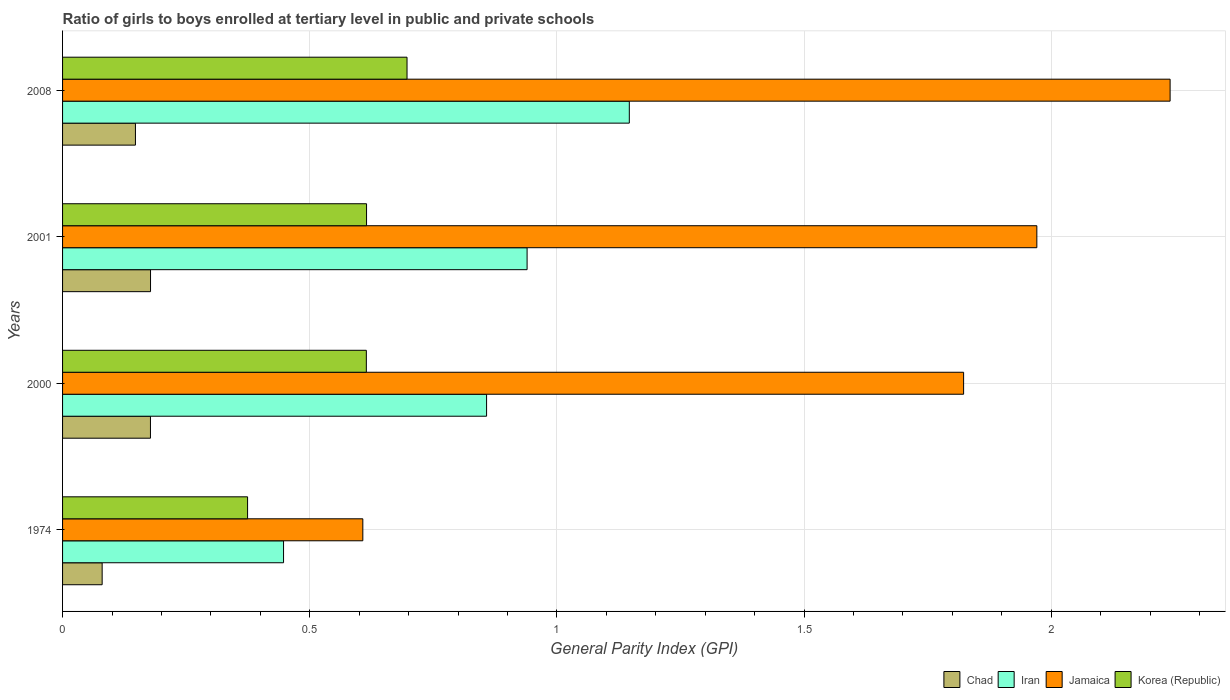How many different coloured bars are there?
Offer a terse response. 4. How many groups of bars are there?
Provide a succinct answer. 4. Are the number of bars per tick equal to the number of legend labels?
Provide a short and direct response. Yes. Are the number of bars on each tick of the Y-axis equal?
Give a very brief answer. Yes. How many bars are there on the 1st tick from the top?
Provide a succinct answer. 4. How many bars are there on the 3rd tick from the bottom?
Make the answer very short. 4. What is the label of the 4th group of bars from the top?
Provide a succinct answer. 1974. What is the general parity index in Chad in 2008?
Ensure brevity in your answer.  0.15. Across all years, what is the maximum general parity index in Iran?
Your answer should be very brief. 1.15. Across all years, what is the minimum general parity index in Jamaica?
Provide a short and direct response. 0.61. In which year was the general parity index in Korea (Republic) maximum?
Give a very brief answer. 2008. In which year was the general parity index in Iran minimum?
Provide a succinct answer. 1974. What is the total general parity index in Chad in the graph?
Provide a short and direct response. 0.58. What is the difference between the general parity index in Iran in 2000 and that in 2001?
Offer a very short reply. -0.08. What is the difference between the general parity index in Jamaica in 2000 and the general parity index in Korea (Republic) in 2001?
Give a very brief answer. 1.21. What is the average general parity index in Jamaica per year?
Provide a short and direct response. 1.66. In the year 1974, what is the difference between the general parity index in Jamaica and general parity index in Chad?
Offer a terse response. 0.53. What is the ratio of the general parity index in Korea (Republic) in 1974 to that in 2001?
Offer a terse response. 0.61. What is the difference between the highest and the second highest general parity index in Korea (Republic)?
Your response must be concise. 0.08. What is the difference between the highest and the lowest general parity index in Chad?
Keep it short and to the point. 0.1. In how many years, is the general parity index in Iran greater than the average general parity index in Iran taken over all years?
Ensure brevity in your answer.  3. Is the sum of the general parity index in Korea (Republic) in 2000 and 2001 greater than the maximum general parity index in Jamaica across all years?
Offer a terse response. No. What does the 3rd bar from the bottom in 2008 represents?
Offer a terse response. Jamaica. Is it the case that in every year, the sum of the general parity index in Chad and general parity index in Korea (Republic) is greater than the general parity index in Jamaica?
Offer a very short reply. No. How many bars are there?
Your answer should be very brief. 16. Are all the bars in the graph horizontal?
Offer a terse response. Yes. How many years are there in the graph?
Provide a succinct answer. 4. What is the difference between two consecutive major ticks on the X-axis?
Offer a very short reply. 0.5. Are the values on the major ticks of X-axis written in scientific E-notation?
Offer a terse response. No. Does the graph contain any zero values?
Provide a short and direct response. No. How many legend labels are there?
Your answer should be compact. 4. How are the legend labels stacked?
Give a very brief answer. Horizontal. What is the title of the graph?
Provide a short and direct response. Ratio of girls to boys enrolled at tertiary level in public and private schools. Does "Turks and Caicos Islands" appear as one of the legend labels in the graph?
Your response must be concise. No. What is the label or title of the X-axis?
Offer a very short reply. General Parity Index (GPI). What is the label or title of the Y-axis?
Ensure brevity in your answer.  Years. What is the General Parity Index (GPI) of Chad in 1974?
Keep it short and to the point. 0.08. What is the General Parity Index (GPI) of Iran in 1974?
Provide a short and direct response. 0.45. What is the General Parity Index (GPI) of Jamaica in 1974?
Provide a succinct answer. 0.61. What is the General Parity Index (GPI) in Korea (Republic) in 1974?
Ensure brevity in your answer.  0.37. What is the General Parity Index (GPI) in Chad in 2000?
Provide a short and direct response. 0.18. What is the General Parity Index (GPI) in Iran in 2000?
Keep it short and to the point. 0.86. What is the General Parity Index (GPI) of Jamaica in 2000?
Offer a terse response. 1.82. What is the General Parity Index (GPI) in Korea (Republic) in 2000?
Your answer should be very brief. 0.61. What is the General Parity Index (GPI) in Chad in 2001?
Provide a short and direct response. 0.18. What is the General Parity Index (GPI) in Iran in 2001?
Make the answer very short. 0.94. What is the General Parity Index (GPI) in Jamaica in 2001?
Offer a very short reply. 1.97. What is the General Parity Index (GPI) in Korea (Republic) in 2001?
Offer a very short reply. 0.61. What is the General Parity Index (GPI) in Chad in 2008?
Keep it short and to the point. 0.15. What is the General Parity Index (GPI) of Iran in 2008?
Keep it short and to the point. 1.15. What is the General Parity Index (GPI) in Jamaica in 2008?
Your answer should be very brief. 2.24. What is the General Parity Index (GPI) of Korea (Republic) in 2008?
Ensure brevity in your answer.  0.7. Across all years, what is the maximum General Parity Index (GPI) of Chad?
Your answer should be compact. 0.18. Across all years, what is the maximum General Parity Index (GPI) in Iran?
Keep it short and to the point. 1.15. Across all years, what is the maximum General Parity Index (GPI) of Jamaica?
Your response must be concise. 2.24. Across all years, what is the maximum General Parity Index (GPI) in Korea (Republic)?
Provide a short and direct response. 0.7. Across all years, what is the minimum General Parity Index (GPI) of Chad?
Your answer should be compact. 0.08. Across all years, what is the minimum General Parity Index (GPI) in Iran?
Offer a terse response. 0.45. Across all years, what is the minimum General Parity Index (GPI) in Jamaica?
Your answer should be very brief. 0.61. Across all years, what is the minimum General Parity Index (GPI) in Korea (Republic)?
Ensure brevity in your answer.  0.37. What is the total General Parity Index (GPI) of Chad in the graph?
Keep it short and to the point. 0.58. What is the total General Parity Index (GPI) in Iran in the graph?
Make the answer very short. 3.39. What is the total General Parity Index (GPI) in Jamaica in the graph?
Offer a terse response. 6.64. What is the total General Parity Index (GPI) of Korea (Republic) in the graph?
Provide a short and direct response. 2.3. What is the difference between the General Parity Index (GPI) in Chad in 1974 and that in 2000?
Offer a terse response. -0.1. What is the difference between the General Parity Index (GPI) of Iran in 1974 and that in 2000?
Keep it short and to the point. -0.41. What is the difference between the General Parity Index (GPI) in Jamaica in 1974 and that in 2000?
Your answer should be compact. -1.22. What is the difference between the General Parity Index (GPI) of Korea (Republic) in 1974 and that in 2000?
Your response must be concise. -0.24. What is the difference between the General Parity Index (GPI) in Chad in 1974 and that in 2001?
Your answer should be compact. -0.1. What is the difference between the General Parity Index (GPI) of Iran in 1974 and that in 2001?
Your response must be concise. -0.49. What is the difference between the General Parity Index (GPI) of Jamaica in 1974 and that in 2001?
Provide a short and direct response. -1.36. What is the difference between the General Parity Index (GPI) in Korea (Republic) in 1974 and that in 2001?
Provide a short and direct response. -0.24. What is the difference between the General Parity Index (GPI) in Chad in 1974 and that in 2008?
Offer a terse response. -0.07. What is the difference between the General Parity Index (GPI) in Iran in 1974 and that in 2008?
Ensure brevity in your answer.  -0.7. What is the difference between the General Parity Index (GPI) of Jamaica in 1974 and that in 2008?
Offer a very short reply. -1.63. What is the difference between the General Parity Index (GPI) of Korea (Republic) in 1974 and that in 2008?
Keep it short and to the point. -0.32. What is the difference between the General Parity Index (GPI) in Chad in 2000 and that in 2001?
Your answer should be compact. -0. What is the difference between the General Parity Index (GPI) of Iran in 2000 and that in 2001?
Keep it short and to the point. -0.08. What is the difference between the General Parity Index (GPI) in Jamaica in 2000 and that in 2001?
Ensure brevity in your answer.  -0.15. What is the difference between the General Parity Index (GPI) in Korea (Republic) in 2000 and that in 2001?
Your response must be concise. -0. What is the difference between the General Parity Index (GPI) in Chad in 2000 and that in 2008?
Your answer should be compact. 0.03. What is the difference between the General Parity Index (GPI) in Iran in 2000 and that in 2008?
Provide a succinct answer. -0.29. What is the difference between the General Parity Index (GPI) in Jamaica in 2000 and that in 2008?
Offer a terse response. -0.42. What is the difference between the General Parity Index (GPI) in Korea (Republic) in 2000 and that in 2008?
Keep it short and to the point. -0.08. What is the difference between the General Parity Index (GPI) in Chad in 2001 and that in 2008?
Your answer should be compact. 0.03. What is the difference between the General Parity Index (GPI) of Iran in 2001 and that in 2008?
Your response must be concise. -0.21. What is the difference between the General Parity Index (GPI) in Jamaica in 2001 and that in 2008?
Offer a very short reply. -0.27. What is the difference between the General Parity Index (GPI) of Korea (Republic) in 2001 and that in 2008?
Offer a terse response. -0.08. What is the difference between the General Parity Index (GPI) in Chad in 1974 and the General Parity Index (GPI) in Iran in 2000?
Your response must be concise. -0.78. What is the difference between the General Parity Index (GPI) in Chad in 1974 and the General Parity Index (GPI) in Jamaica in 2000?
Your answer should be very brief. -1.74. What is the difference between the General Parity Index (GPI) of Chad in 1974 and the General Parity Index (GPI) of Korea (Republic) in 2000?
Your response must be concise. -0.53. What is the difference between the General Parity Index (GPI) in Iran in 1974 and the General Parity Index (GPI) in Jamaica in 2000?
Offer a very short reply. -1.38. What is the difference between the General Parity Index (GPI) of Iran in 1974 and the General Parity Index (GPI) of Korea (Republic) in 2000?
Offer a very short reply. -0.17. What is the difference between the General Parity Index (GPI) of Jamaica in 1974 and the General Parity Index (GPI) of Korea (Republic) in 2000?
Provide a succinct answer. -0.01. What is the difference between the General Parity Index (GPI) in Chad in 1974 and the General Parity Index (GPI) in Iran in 2001?
Your answer should be very brief. -0.86. What is the difference between the General Parity Index (GPI) in Chad in 1974 and the General Parity Index (GPI) in Jamaica in 2001?
Your answer should be compact. -1.89. What is the difference between the General Parity Index (GPI) in Chad in 1974 and the General Parity Index (GPI) in Korea (Republic) in 2001?
Ensure brevity in your answer.  -0.53. What is the difference between the General Parity Index (GPI) of Iran in 1974 and the General Parity Index (GPI) of Jamaica in 2001?
Ensure brevity in your answer.  -1.52. What is the difference between the General Parity Index (GPI) in Iran in 1974 and the General Parity Index (GPI) in Korea (Republic) in 2001?
Offer a very short reply. -0.17. What is the difference between the General Parity Index (GPI) in Jamaica in 1974 and the General Parity Index (GPI) in Korea (Republic) in 2001?
Make the answer very short. -0.01. What is the difference between the General Parity Index (GPI) of Chad in 1974 and the General Parity Index (GPI) of Iran in 2008?
Ensure brevity in your answer.  -1.07. What is the difference between the General Parity Index (GPI) of Chad in 1974 and the General Parity Index (GPI) of Jamaica in 2008?
Offer a terse response. -2.16. What is the difference between the General Parity Index (GPI) of Chad in 1974 and the General Parity Index (GPI) of Korea (Republic) in 2008?
Your answer should be compact. -0.62. What is the difference between the General Parity Index (GPI) of Iran in 1974 and the General Parity Index (GPI) of Jamaica in 2008?
Offer a terse response. -1.79. What is the difference between the General Parity Index (GPI) of Iran in 1974 and the General Parity Index (GPI) of Korea (Republic) in 2008?
Give a very brief answer. -0.25. What is the difference between the General Parity Index (GPI) of Jamaica in 1974 and the General Parity Index (GPI) of Korea (Republic) in 2008?
Offer a very short reply. -0.09. What is the difference between the General Parity Index (GPI) in Chad in 2000 and the General Parity Index (GPI) in Iran in 2001?
Ensure brevity in your answer.  -0.76. What is the difference between the General Parity Index (GPI) of Chad in 2000 and the General Parity Index (GPI) of Jamaica in 2001?
Your response must be concise. -1.79. What is the difference between the General Parity Index (GPI) in Chad in 2000 and the General Parity Index (GPI) in Korea (Republic) in 2001?
Keep it short and to the point. -0.44. What is the difference between the General Parity Index (GPI) in Iran in 2000 and the General Parity Index (GPI) in Jamaica in 2001?
Ensure brevity in your answer.  -1.11. What is the difference between the General Parity Index (GPI) of Iran in 2000 and the General Parity Index (GPI) of Korea (Republic) in 2001?
Keep it short and to the point. 0.24. What is the difference between the General Parity Index (GPI) of Jamaica in 2000 and the General Parity Index (GPI) of Korea (Republic) in 2001?
Offer a terse response. 1.21. What is the difference between the General Parity Index (GPI) in Chad in 2000 and the General Parity Index (GPI) in Iran in 2008?
Your answer should be compact. -0.97. What is the difference between the General Parity Index (GPI) in Chad in 2000 and the General Parity Index (GPI) in Jamaica in 2008?
Your answer should be very brief. -2.06. What is the difference between the General Parity Index (GPI) in Chad in 2000 and the General Parity Index (GPI) in Korea (Republic) in 2008?
Give a very brief answer. -0.52. What is the difference between the General Parity Index (GPI) in Iran in 2000 and the General Parity Index (GPI) in Jamaica in 2008?
Your answer should be compact. -1.38. What is the difference between the General Parity Index (GPI) in Iran in 2000 and the General Parity Index (GPI) in Korea (Republic) in 2008?
Your answer should be compact. 0.16. What is the difference between the General Parity Index (GPI) in Jamaica in 2000 and the General Parity Index (GPI) in Korea (Republic) in 2008?
Offer a terse response. 1.13. What is the difference between the General Parity Index (GPI) of Chad in 2001 and the General Parity Index (GPI) of Iran in 2008?
Provide a short and direct response. -0.97. What is the difference between the General Parity Index (GPI) in Chad in 2001 and the General Parity Index (GPI) in Jamaica in 2008?
Provide a short and direct response. -2.06. What is the difference between the General Parity Index (GPI) of Chad in 2001 and the General Parity Index (GPI) of Korea (Republic) in 2008?
Offer a very short reply. -0.52. What is the difference between the General Parity Index (GPI) of Iran in 2001 and the General Parity Index (GPI) of Jamaica in 2008?
Give a very brief answer. -1.3. What is the difference between the General Parity Index (GPI) of Iran in 2001 and the General Parity Index (GPI) of Korea (Republic) in 2008?
Provide a short and direct response. 0.24. What is the difference between the General Parity Index (GPI) of Jamaica in 2001 and the General Parity Index (GPI) of Korea (Republic) in 2008?
Your answer should be compact. 1.27. What is the average General Parity Index (GPI) in Chad per year?
Offer a very short reply. 0.15. What is the average General Parity Index (GPI) in Iran per year?
Provide a short and direct response. 0.85. What is the average General Parity Index (GPI) in Jamaica per year?
Keep it short and to the point. 1.66. What is the average General Parity Index (GPI) in Korea (Republic) per year?
Make the answer very short. 0.58. In the year 1974, what is the difference between the General Parity Index (GPI) in Chad and General Parity Index (GPI) in Iran?
Provide a succinct answer. -0.37. In the year 1974, what is the difference between the General Parity Index (GPI) of Chad and General Parity Index (GPI) of Jamaica?
Provide a short and direct response. -0.53. In the year 1974, what is the difference between the General Parity Index (GPI) of Chad and General Parity Index (GPI) of Korea (Republic)?
Your response must be concise. -0.29. In the year 1974, what is the difference between the General Parity Index (GPI) of Iran and General Parity Index (GPI) of Jamaica?
Offer a terse response. -0.16. In the year 1974, what is the difference between the General Parity Index (GPI) of Iran and General Parity Index (GPI) of Korea (Republic)?
Offer a very short reply. 0.07. In the year 1974, what is the difference between the General Parity Index (GPI) of Jamaica and General Parity Index (GPI) of Korea (Republic)?
Provide a succinct answer. 0.23. In the year 2000, what is the difference between the General Parity Index (GPI) in Chad and General Parity Index (GPI) in Iran?
Give a very brief answer. -0.68. In the year 2000, what is the difference between the General Parity Index (GPI) in Chad and General Parity Index (GPI) in Jamaica?
Your response must be concise. -1.64. In the year 2000, what is the difference between the General Parity Index (GPI) in Chad and General Parity Index (GPI) in Korea (Republic)?
Your response must be concise. -0.44. In the year 2000, what is the difference between the General Parity Index (GPI) in Iran and General Parity Index (GPI) in Jamaica?
Make the answer very short. -0.96. In the year 2000, what is the difference between the General Parity Index (GPI) in Iran and General Parity Index (GPI) in Korea (Republic)?
Offer a terse response. 0.24. In the year 2000, what is the difference between the General Parity Index (GPI) of Jamaica and General Parity Index (GPI) of Korea (Republic)?
Provide a succinct answer. 1.21. In the year 2001, what is the difference between the General Parity Index (GPI) of Chad and General Parity Index (GPI) of Iran?
Offer a very short reply. -0.76. In the year 2001, what is the difference between the General Parity Index (GPI) of Chad and General Parity Index (GPI) of Jamaica?
Your answer should be very brief. -1.79. In the year 2001, what is the difference between the General Parity Index (GPI) in Chad and General Parity Index (GPI) in Korea (Republic)?
Your answer should be compact. -0.44. In the year 2001, what is the difference between the General Parity Index (GPI) of Iran and General Parity Index (GPI) of Jamaica?
Give a very brief answer. -1.03. In the year 2001, what is the difference between the General Parity Index (GPI) in Iran and General Parity Index (GPI) in Korea (Republic)?
Your answer should be very brief. 0.32. In the year 2001, what is the difference between the General Parity Index (GPI) of Jamaica and General Parity Index (GPI) of Korea (Republic)?
Give a very brief answer. 1.36. In the year 2008, what is the difference between the General Parity Index (GPI) in Chad and General Parity Index (GPI) in Iran?
Keep it short and to the point. -1. In the year 2008, what is the difference between the General Parity Index (GPI) of Chad and General Parity Index (GPI) of Jamaica?
Make the answer very short. -2.09. In the year 2008, what is the difference between the General Parity Index (GPI) of Chad and General Parity Index (GPI) of Korea (Republic)?
Provide a short and direct response. -0.55. In the year 2008, what is the difference between the General Parity Index (GPI) in Iran and General Parity Index (GPI) in Jamaica?
Give a very brief answer. -1.09. In the year 2008, what is the difference between the General Parity Index (GPI) in Iran and General Parity Index (GPI) in Korea (Republic)?
Offer a terse response. 0.45. In the year 2008, what is the difference between the General Parity Index (GPI) in Jamaica and General Parity Index (GPI) in Korea (Republic)?
Offer a very short reply. 1.54. What is the ratio of the General Parity Index (GPI) of Chad in 1974 to that in 2000?
Make the answer very short. 0.45. What is the ratio of the General Parity Index (GPI) of Iran in 1974 to that in 2000?
Your answer should be compact. 0.52. What is the ratio of the General Parity Index (GPI) of Jamaica in 1974 to that in 2000?
Your answer should be compact. 0.33. What is the ratio of the General Parity Index (GPI) in Korea (Republic) in 1974 to that in 2000?
Your answer should be compact. 0.61. What is the ratio of the General Parity Index (GPI) of Chad in 1974 to that in 2001?
Give a very brief answer. 0.45. What is the ratio of the General Parity Index (GPI) of Iran in 1974 to that in 2001?
Provide a succinct answer. 0.48. What is the ratio of the General Parity Index (GPI) in Jamaica in 1974 to that in 2001?
Give a very brief answer. 0.31. What is the ratio of the General Parity Index (GPI) in Korea (Republic) in 1974 to that in 2001?
Offer a very short reply. 0.61. What is the ratio of the General Parity Index (GPI) in Chad in 1974 to that in 2008?
Your answer should be compact. 0.54. What is the ratio of the General Parity Index (GPI) in Iran in 1974 to that in 2008?
Provide a short and direct response. 0.39. What is the ratio of the General Parity Index (GPI) of Jamaica in 1974 to that in 2008?
Make the answer very short. 0.27. What is the ratio of the General Parity Index (GPI) of Korea (Republic) in 1974 to that in 2008?
Provide a succinct answer. 0.54. What is the ratio of the General Parity Index (GPI) in Iran in 2000 to that in 2001?
Offer a terse response. 0.91. What is the ratio of the General Parity Index (GPI) in Jamaica in 2000 to that in 2001?
Offer a very short reply. 0.92. What is the ratio of the General Parity Index (GPI) of Chad in 2000 to that in 2008?
Make the answer very short. 1.21. What is the ratio of the General Parity Index (GPI) of Iran in 2000 to that in 2008?
Give a very brief answer. 0.75. What is the ratio of the General Parity Index (GPI) of Jamaica in 2000 to that in 2008?
Your answer should be very brief. 0.81. What is the ratio of the General Parity Index (GPI) in Korea (Republic) in 2000 to that in 2008?
Provide a short and direct response. 0.88. What is the ratio of the General Parity Index (GPI) of Chad in 2001 to that in 2008?
Offer a terse response. 1.21. What is the ratio of the General Parity Index (GPI) in Iran in 2001 to that in 2008?
Provide a succinct answer. 0.82. What is the ratio of the General Parity Index (GPI) in Jamaica in 2001 to that in 2008?
Offer a terse response. 0.88. What is the ratio of the General Parity Index (GPI) in Korea (Republic) in 2001 to that in 2008?
Your response must be concise. 0.88. What is the difference between the highest and the second highest General Parity Index (GPI) of Chad?
Offer a very short reply. 0. What is the difference between the highest and the second highest General Parity Index (GPI) in Iran?
Give a very brief answer. 0.21. What is the difference between the highest and the second highest General Parity Index (GPI) in Jamaica?
Offer a terse response. 0.27. What is the difference between the highest and the second highest General Parity Index (GPI) in Korea (Republic)?
Your response must be concise. 0.08. What is the difference between the highest and the lowest General Parity Index (GPI) of Chad?
Offer a terse response. 0.1. What is the difference between the highest and the lowest General Parity Index (GPI) in Iran?
Offer a very short reply. 0.7. What is the difference between the highest and the lowest General Parity Index (GPI) in Jamaica?
Ensure brevity in your answer.  1.63. What is the difference between the highest and the lowest General Parity Index (GPI) in Korea (Republic)?
Your answer should be very brief. 0.32. 